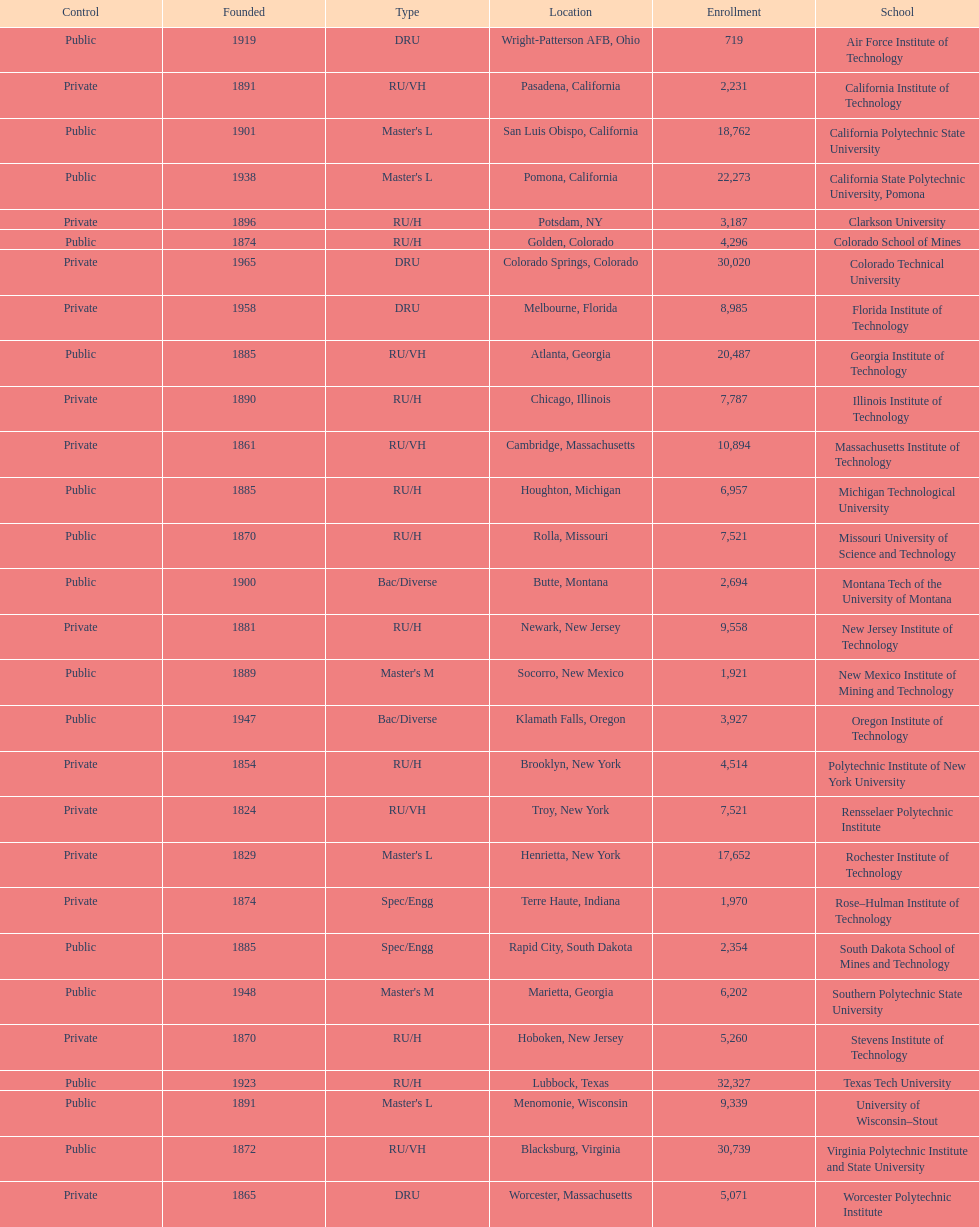Parse the table in full. {'header': ['Control', 'Founded', 'Type', 'Location', 'Enrollment', 'School'], 'rows': [['Public', '1919', 'DRU', 'Wright-Patterson AFB, Ohio', '719', 'Air Force Institute of Technology'], ['Private', '1891', 'RU/VH', 'Pasadena, California', '2,231', 'California Institute of Technology'], ['Public', '1901', "Master's L", 'San Luis Obispo, California', '18,762', 'California Polytechnic State University'], ['Public', '1938', "Master's L", 'Pomona, California', '22,273', 'California State Polytechnic University, Pomona'], ['Private', '1896', 'RU/H', 'Potsdam, NY', '3,187', 'Clarkson University'], ['Public', '1874', 'RU/H', 'Golden, Colorado', '4,296', 'Colorado School of Mines'], ['Private', '1965', 'DRU', 'Colorado Springs, Colorado', '30,020', 'Colorado Technical University'], ['Private', '1958', 'DRU', 'Melbourne, Florida', '8,985', 'Florida Institute of Technology'], ['Public', '1885', 'RU/VH', 'Atlanta, Georgia', '20,487', 'Georgia Institute of Technology'], ['Private', '1890', 'RU/H', 'Chicago, Illinois', '7,787', 'Illinois Institute of Technology'], ['Private', '1861', 'RU/VH', 'Cambridge, Massachusetts', '10,894', 'Massachusetts Institute of Technology'], ['Public', '1885', 'RU/H', 'Houghton, Michigan', '6,957', 'Michigan Technological University'], ['Public', '1870', 'RU/H', 'Rolla, Missouri', '7,521', 'Missouri University of Science and Technology'], ['Public', '1900', 'Bac/Diverse', 'Butte, Montana', '2,694', 'Montana Tech of the University of Montana'], ['Private', '1881', 'RU/H', 'Newark, New Jersey', '9,558', 'New Jersey Institute of Technology'], ['Public', '1889', "Master's M", 'Socorro, New Mexico', '1,921', 'New Mexico Institute of Mining and Technology'], ['Public', '1947', 'Bac/Diverse', 'Klamath Falls, Oregon', '3,927', 'Oregon Institute of Technology'], ['Private', '1854', 'RU/H', 'Brooklyn, New York', '4,514', 'Polytechnic Institute of New York University'], ['Private', '1824', 'RU/VH', 'Troy, New York', '7,521', 'Rensselaer Polytechnic Institute'], ['Private', '1829', "Master's L", 'Henrietta, New York', '17,652', 'Rochester Institute of Technology'], ['Private', '1874', 'Spec/Engg', 'Terre Haute, Indiana', '1,970', 'Rose–Hulman Institute of Technology'], ['Public', '1885', 'Spec/Engg', 'Rapid City, South Dakota', '2,354', 'South Dakota School of Mines and Technology'], ['Public', '1948', "Master's M", 'Marietta, Georgia', '6,202', 'Southern Polytechnic State University'], ['Private', '1870', 'RU/H', 'Hoboken, New Jersey', '5,260', 'Stevens Institute of Technology'], ['Public', '1923', 'RU/H', 'Lubbock, Texas', '32,327', 'Texas Tech University'], ['Public', '1891', "Master's L", 'Menomonie, Wisconsin', '9,339', 'University of Wisconsin–Stout'], ['Public', '1872', 'RU/VH', 'Blacksburg, Virginia', '30,739', 'Virginia Polytechnic Institute and State University'], ['Private', '1865', 'DRU', 'Worcester, Massachusetts', '5,071', 'Worcester Polytechnic Institute']]} What is the number of us technological schools in the state of california? 3. 